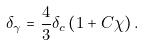<formula> <loc_0><loc_0><loc_500><loc_500>\delta _ { \gamma } = \frac { 4 } { 3 } \delta _ { c } \left ( 1 + C \chi \right ) .</formula> 